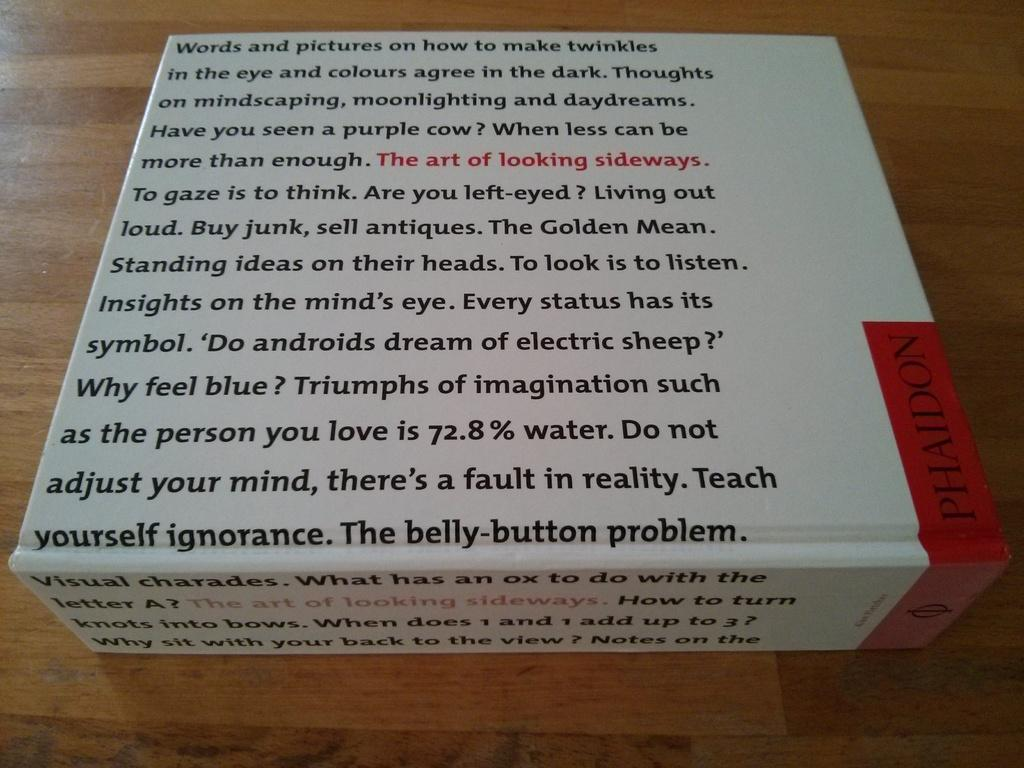<image>
Create a compact narrative representing the image presented. A white box covered in text including the questions "Do Androids Dream of Electric Sheep?" 